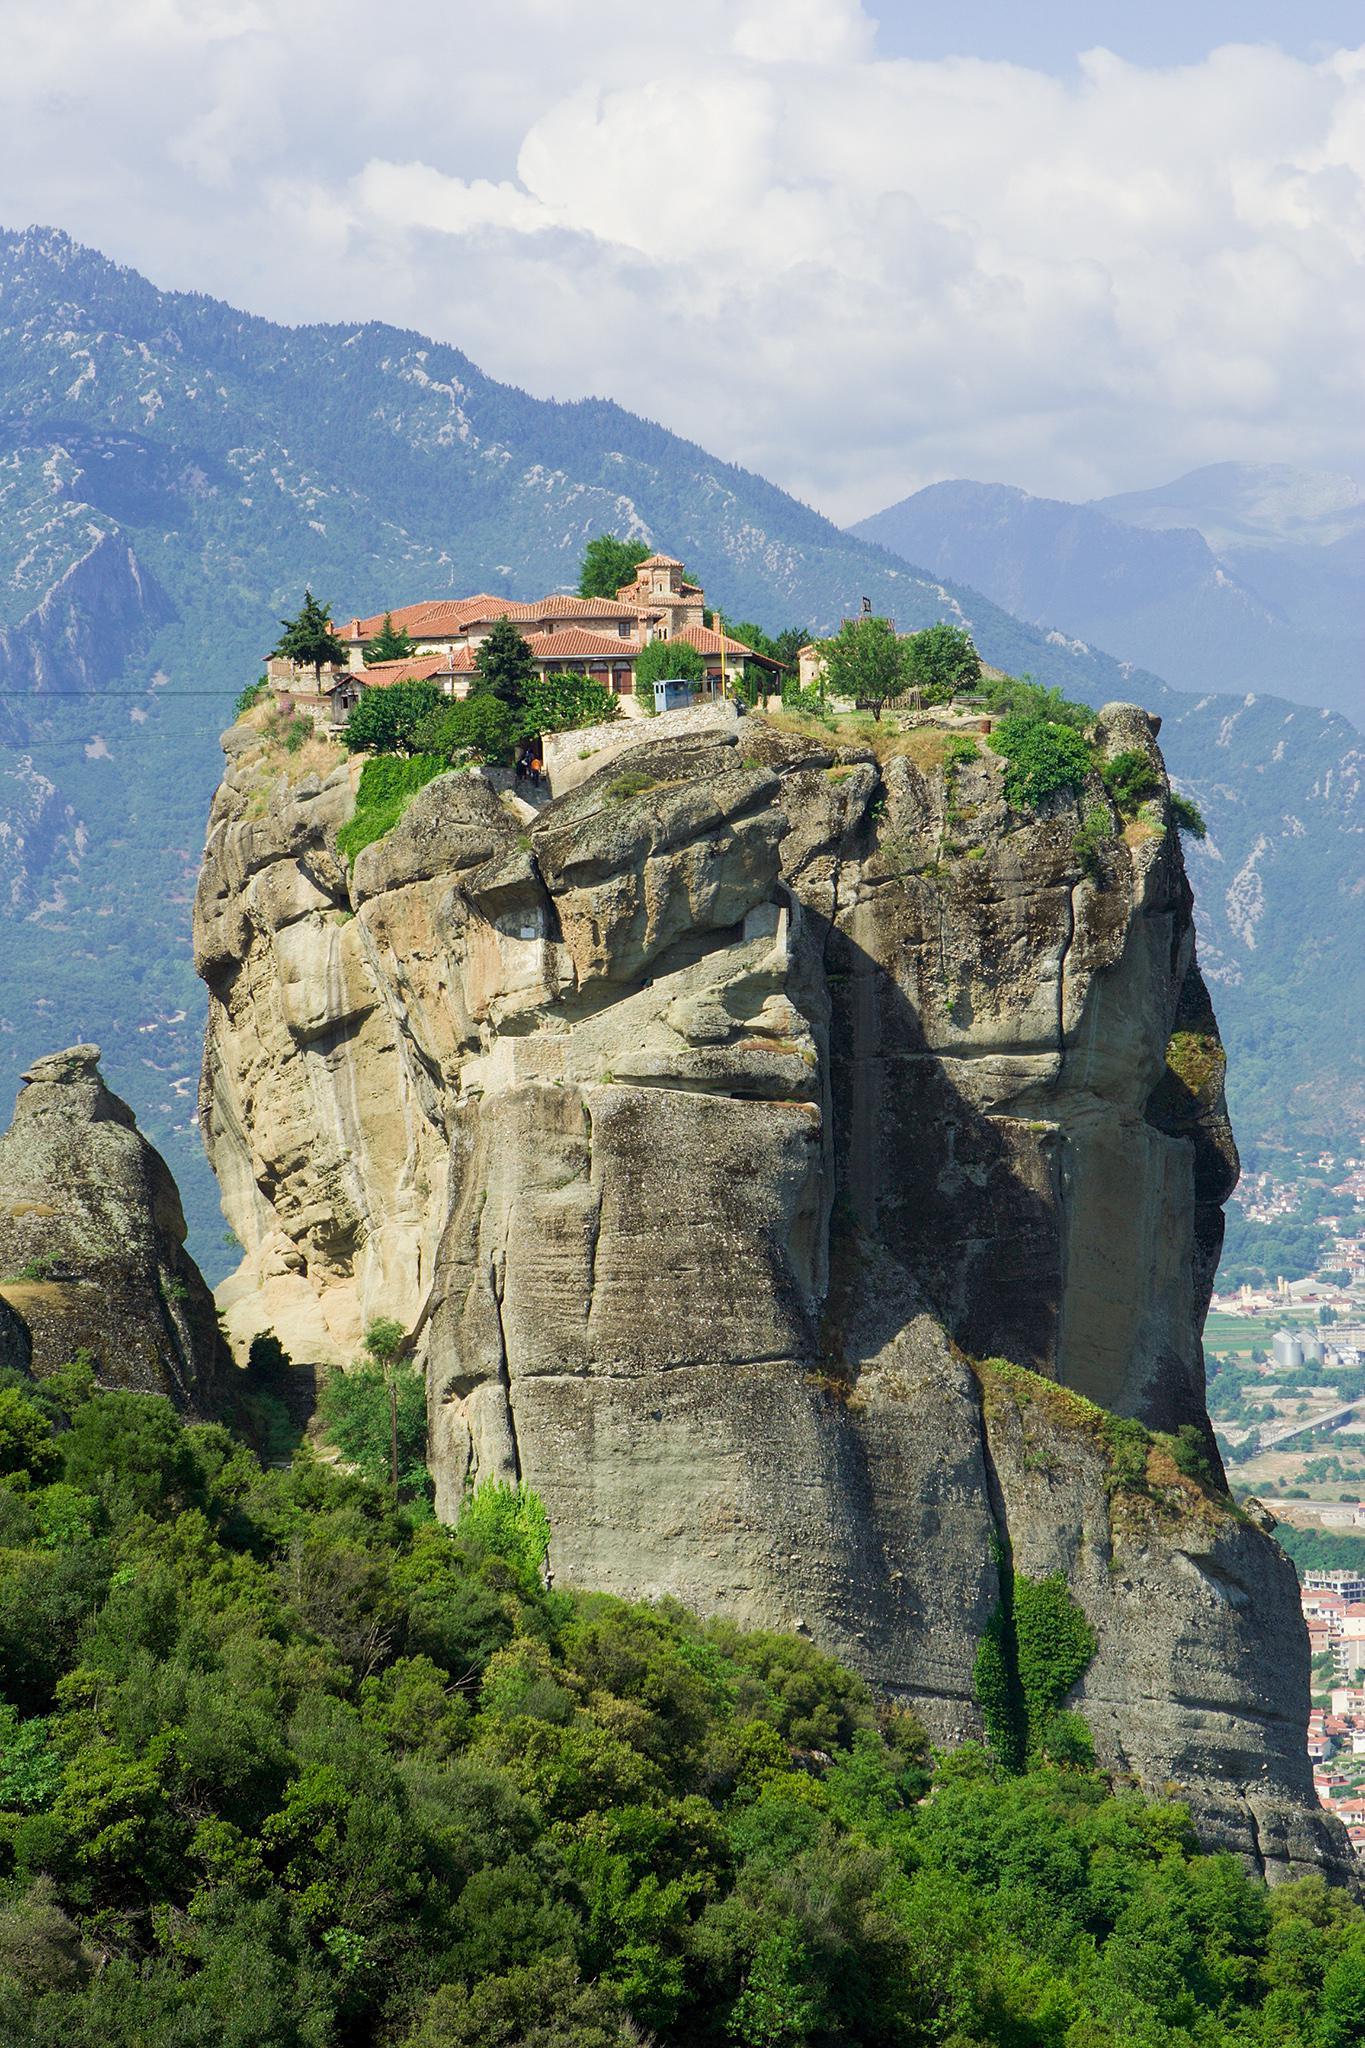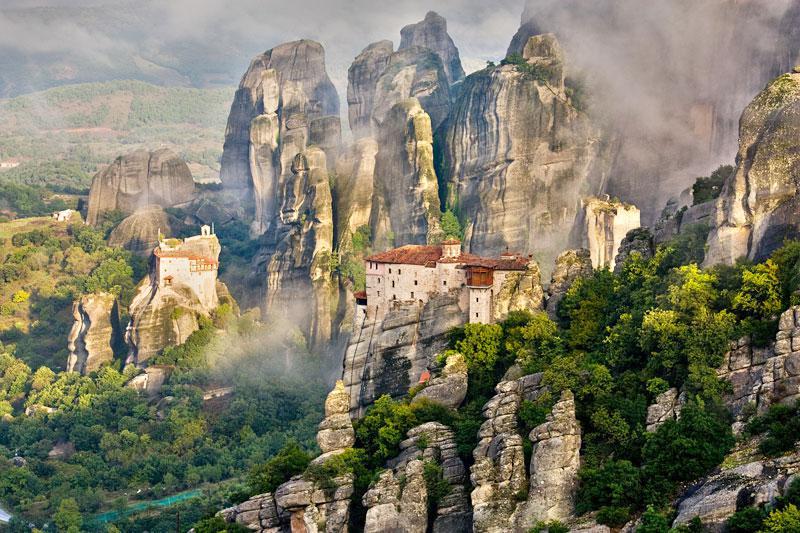The first image is the image on the left, the second image is the image on the right. Examine the images to the left and right. Is the description "There is visible fog in one of the images." accurate? Answer yes or no. Yes. The first image is the image on the left, the second image is the image on the right. Evaluate the accuracy of this statement regarding the images: "One image has misty clouds in between mountains.". Is it true? Answer yes or no. Yes. 